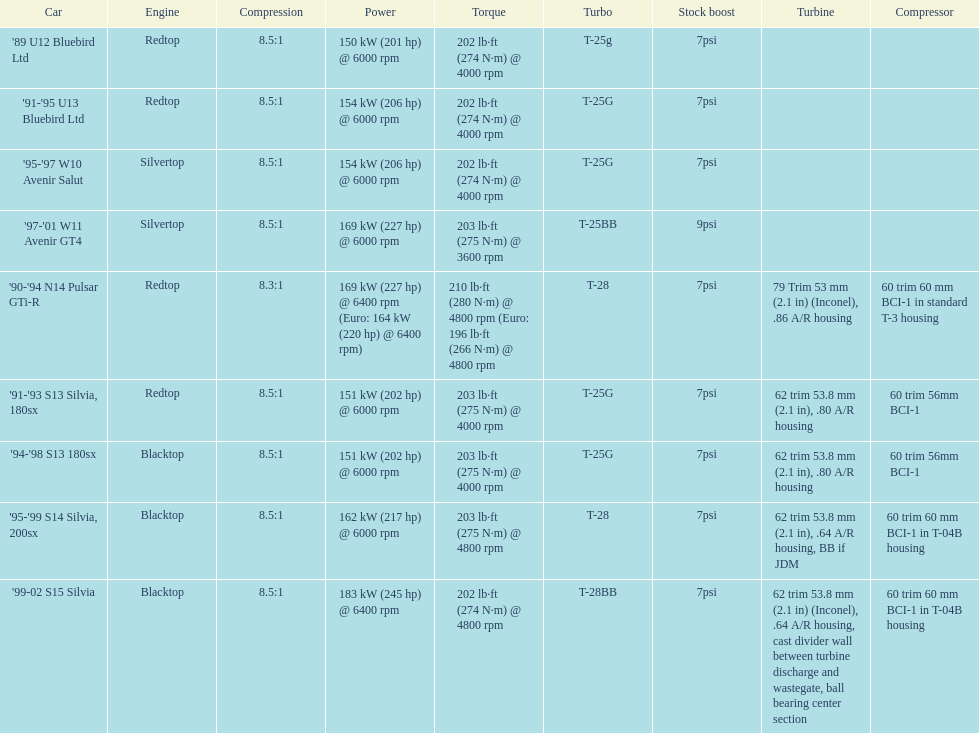In which car is the power measurement above 6000 rpm? '90-'94 N14 Pulsar GTi-R, '99-02 S15 Silvia. 